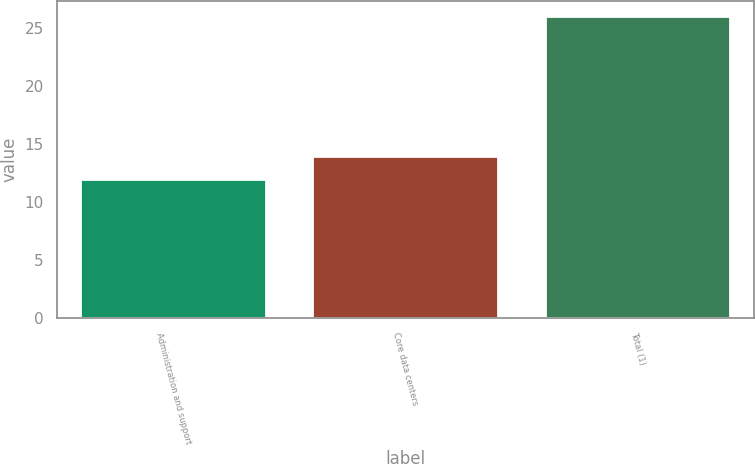Convert chart to OTSL. <chart><loc_0><loc_0><loc_500><loc_500><bar_chart><fcel>Administration and support<fcel>Core data centers<fcel>Total (1)<nl><fcel>12<fcel>14<fcel>26<nl></chart> 